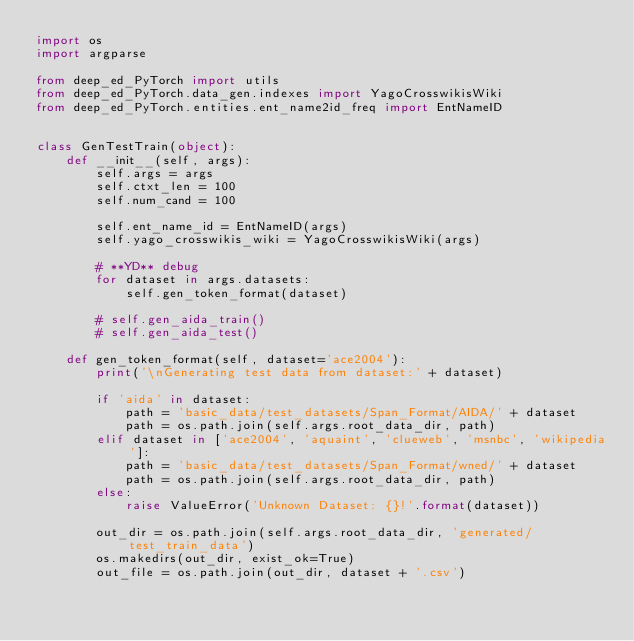<code> <loc_0><loc_0><loc_500><loc_500><_Python_>import os
import argparse

from deep_ed_PyTorch import utils
from deep_ed_PyTorch.data_gen.indexes import YagoCrosswikisWiki
from deep_ed_PyTorch.entities.ent_name2id_freq import EntNameID


class GenTestTrain(object):
    def __init__(self, args):
        self.args = args
        self.ctxt_len = 100
        self.num_cand = 100

        self.ent_name_id = EntNameID(args)
        self.yago_crosswikis_wiki = YagoCrosswikisWiki(args)

        # **YD** debug
        for dataset in args.datasets:
            self.gen_token_format(dataset)

        # self.gen_aida_train()
        # self.gen_aida_test()

    def gen_token_format(self, dataset='ace2004'):
        print('\nGenerating test data from dataset:' + dataset)

        if 'aida' in dataset:
            path = 'basic_data/test_datasets/Span_Format/AIDA/' + dataset
            path = os.path.join(self.args.root_data_dir, path)
        elif dataset in ['ace2004', 'aquaint', 'clueweb', 'msnbc', 'wikipedia']:
            path = 'basic_data/test_datasets/Span_Format/wned/' + dataset
            path = os.path.join(self.args.root_data_dir, path)
        else:
            raise ValueError('Unknown Dataset: {}!'.format(dataset))

        out_dir = os.path.join(self.args.root_data_dir, 'generated/test_train_data')
        os.makedirs(out_dir, exist_ok=True)
        out_file = os.path.join(out_dir, dataset + '.csv')</code> 